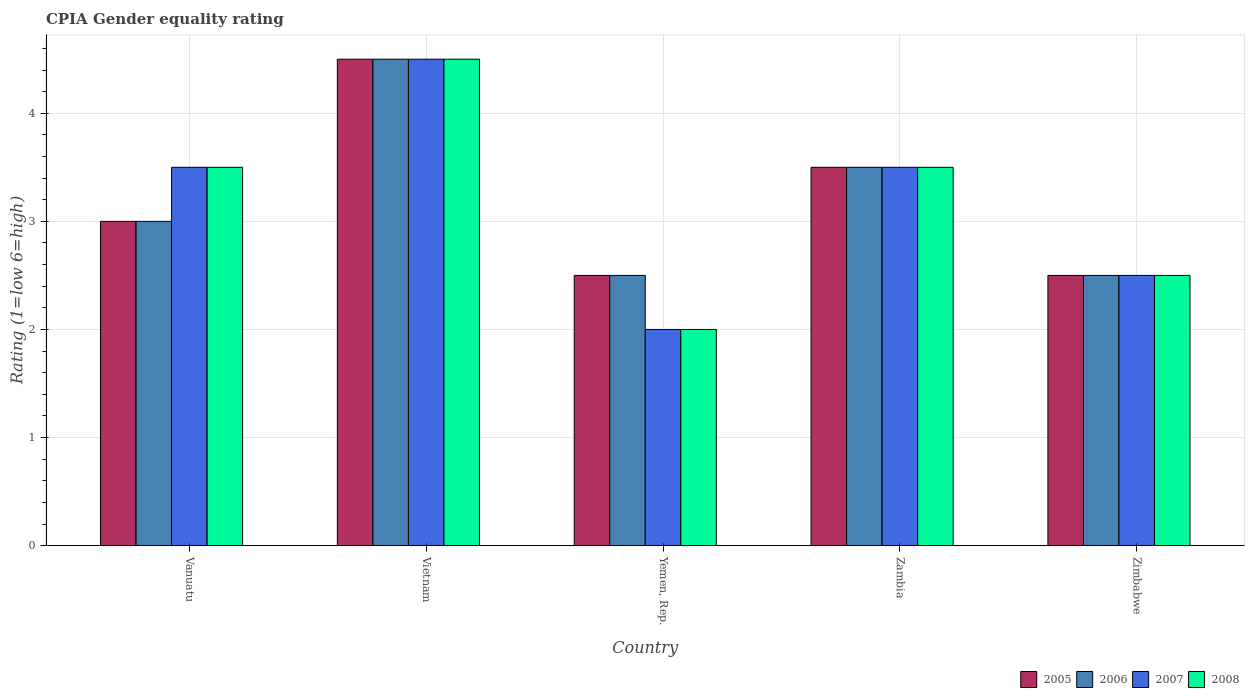How many different coloured bars are there?
Provide a succinct answer. 4. Are the number of bars per tick equal to the number of legend labels?
Your answer should be compact. Yes. Are the number of bars on each tick of the X-axis equal?
Your answer should be compact. Yes. What is the label of the 1st group of bars from the left?
Provide a succinct answer. Vanuatu. In how many cases, is the number of bars for a given country not equal to the number of legend labels?
Make the answer very short. 0. Across all countries, what is the maximum CPIA rating in 2005?
Offer a terse response. 4.5. In which country was the CPIA rating in 2006 maximum?
Ensure brevity in your answer.  Vietnam. In which country was the CPIA rating in 2008 minimum?
Keep it short and to the point. Yemen, Rep. What is the ratio of the CPIA rating in 2007 in Vietnam to that in Zimbabwe?
Give a very brief answer. 1.8. Is the CPIA rating in 2005 in Yemen, Rep. less than that in Zambia?
Your answer should be very brief. Yes. Is the difference between the CPIA rating in 2005 in Yemen, Rep. and Zimbabwe greater than the difference between the CPIA rating in 2008 in Yemen, Rep. and Zimbabwe?
Your response must be concise. Yes. What is the difference between the highest and the lowest CPIA rating in 2006?
Ensure brevity in your answer.  2. Is it the case that in every country, the sum of the CPIA rating in 2008 and CPIA rating in 2005 is greater than the sum of CPIA rating in 2007 and CPIA rating in 2006?
Provide a short and direct response. No. Is it the case that in every country, the sum of the CPIA rating in 2007 and CPIA rating in 2005 is greater than the CPIA rating in 2006?
Your answer should be compact. Yes. Are all the bars in the graph horizontal?
Your answer should be very brief. No. What is the difference between two consecutive major ticks on the Y-axis?
Offer a very short reply. 1. Are the values on the major ticks of Y-axis written in scientific E-notation?
Your answer should be compact. No. Does the graph contain grids?
Offer a very short reply. Yes. How many legend labels are there?
Make the answer very short. 4. How are the legend labels stacked?
Your answer should be very brief. Horizontal. What is the title of the graph?
Offer a terse response. CPIA Gender equality rating. What is the label or title of the X-axis?
Your response must be concise. Country. What is the Rating (1=low 6=high) of 2007 in Vanuatu?
Your answer should be compact. 3.5. What is the Rating (1=low 6=high) in 2007 in Vietnam?
Provide a short and direct response. 4.5. What is the Rating (1=low 6=high) in 2007 in Yemen, Rep.?
Your answer should be very brief. 2. What is the Rating (1=low 6=high) of 2008 in Zambia?
Ensure brevity in your answer.  3.5. What is the Rating (1=low 6=high) in 2005 in Zimbabwe?
Provide a succinct answer. 2.5. What is the Rating (1=low 6=high) of 2006 in Zimbabwe?
Ensure brevity in your answer.  2.5. What is the Rating (1=low 6=high) of 2008 in Zimbabwe?
Offer a very short reply. 2.5. Across all countries, what is the maximum Rating (1=low 6=high) of 2006?
Make the answer very short. 4.5. Across all countries, what is the maximum Rating (1=low 6=high) of 2007?
Provide a short and direct response. 4.5. Across all countries, what is the minimum Rating (1=low 6=high) of 2006?
Your answer should be very brief. 2.5. Across all countries, what is the minimum Rating (1=low 6=high) in 2007?
Your answer should be very brief. 2. What is the total Rating (1=low 6=high) in 2005 in the graph?
Offer a very short reply. 16. What is the total Rating (1=low 6=high) of 2006 in the graph?
Ensure brevity in your answer.  16. What is the difference between the Rating (1=low 6=high) in 2005 in Vanuatu and that in Vietnam?
Your response must be concise. -1.5. What is the difference between the Rating (1=low 6=high) of 2008 in Vanuatu and that in Vietnam?
Provide a succinct answer. -1. What is the difference between the Rating (1=low 6=high) of 2005 in Vanuatu and that in Yemen, Rep.?
Your answer should be compact. 0.5. What is the difference between the Rating (1=low 6=high) in 2006 in Vanuatu and that in Yemen, Rep.?
Provide a succinct answer. 0.5. What is the difference between the Rating (1=low 6=high) in 2007 in Vanuatu and that in Yemen, Rep.?
Give a very brief answer. 1.5. What is the difference between the Rating (1=low 6=high) of 2005 in Vanuatu and that in Zambia?
Your answer should be compact. -0.5. What is the difference between the Rating (1=low 6=high) in 2006 in Vanuatu and that in Zambia?
Your response must be concise. -0.5. What is the difference between the Rating (1=low 6=high) of 2005 in Vanuatu and that in Zimbabwe?
Provide a short and direct response. 0.5. What is the difference between the Rating (1=low 6=high) of 2006 in Vanuatu and that in Zimbabwe?
Your answer should be compact. 0.5. What is the difference between the Rating (1=low 6=high) of 2007 in Vietnam and that in Yemen, Rep.?
Provide a succinct answer. 2.5. What is the difference between the Rating (1=low 6=high) of 2008 in Vietnam and that in Yemen, Rep.?
Offer a very short reply. 2.5. What is the difference between the Rating (1=low 6=high) of 2005 in Vietnam and that in Zambia?
Offer a very short reply. 1. What is the difference between the Rating (1=low 6=high) in 2006 in Vietnam and that in Zambia?
Provide a short and direct response. 1. What is the difference between the Rating (1=low 6=high) in 2007 in Vietnam and that in Zambia?
Keep it short and to the point. 1. What is the difference between the Rating (1=low 6=high) in 2008 in Vietnam and that in Zambia?
Your answer should be compact. 1. What is the difference between the Rating (1=low 6=high) of 2005 in Vietnam and that in Zimbabwe?
Offer a terse response. 2. What is the difference between the Rating (1=low 6=high) in 2008 in Vietnam and that in Zimbabwe?
Offer a very short reply. 2. What is the difference between the Rating (1=low 6=high) in 2007 in Yemen, Rep. and that in Zambia?
Your answer should be compact. -1.5. What is the difference between the Rating (1=low 6=high) in 2006 in Yemen, Rep. and that in Zimbabwe?
Make the answer very short. 0. What is the difference between the Rating (1=low 6=high) in 2008 in Yemen, Rep. and that in Zimbabwe?
Offer a terse response. -0.5. What is the difference between the Rating (1=low 6=high) of 2006 in Zambia and that in Zimbabwe?
Your answer should be very brief. 1. What is the difference between the Rating (1=low 6=high) in 2007 in Zambia and that in Zimbabwe?
Provide a succinct answer. 1. What is the difference between the Rating (1=low 6=high) in 2005 in Vanuatu and the Rating (1=low 6=high) in 2006 in Vietnam?
Keep it short and to the point. -1.5. What is the difference between the Rating (1=low 6=high) in 2005 in Vanuatu and the Rating (1=low 6=high) in 2007 in Vietnam?
Give a very brief answer. -1.5. What is the difference between the Rating (1=low 6=high) in 2005 in Vanuatu and the Rating (1=low 6=high) in 2008 in Vietnam?
Keep it short and to the point. -1.5. What is the difference between the Rating (1=low 6=high) in 2006 in Vanuatu and the Rating (1=low 6=high) in 2007 in Vietnam?
Give a very brief answer. -1.5. What is the difference between the Rating (1=low 6=high) of 2007 in Vanuatu and the Rating (1=low 6=high) of 2008 in Vietnam?
Your response must be concise. -1. What is the difference between the Rating (1=low 6=high) in 2005 in Vanuatu and the Rating (1=low 6=high) in 2007 in Yemen, Rep.?
Provide a short and direct response. 1. What is the difference between the Rating (1=low 6=high) in 2007 in Vanuatu and the Rating (1=low 6=high) in 2008 in Yemen, Rep.?
Ensure brevity in your answer.  1.5. What is the difference between the Rating (1=low 6=high) in 2007 in Vanuatu and the Rating (1=low 6=high) in 2008 in Zambia?
Keep it short and to the point. 0. What is the difference between the Rating (1=low 6=high) in 2005 in Vanuatu and the Rating (1=low 6=high) in 2006 in Zimbabwe?
Offer a terse response. 0.5. What is the difference between the Rating (1=low 6=high) of 2006 in Vanuatu and the Rating (1=low 6=high) of 2008 in Zimbabwe?
Offer a very short reply. 0.5. What is the difference between the Rating (1=low 6=high) in 2007 in Vanuatu and the Rating (1=low 6=high) in 2008 in Zimbabwe?
Your response must be concise. 1. What is the difference between the Rating (1=low 6=high) in 2005 in Vietnam and the Rating (1=low 6=high) in 2006 in Yemen, Rep.?
Provide a short and direct response. 2. What is the difference between the Rating (1=low 6=high) in 2005 in Vietnam and the Rating (1=low 6=high) in 2007 in Yemen, Rep.?
Ensure brevity in your answer.  2.5. What is the difference between the Rating (1=low 6=high) in 2006 in Vietnam and the Rating (1=low 6=high) in 2007 in Yemen, Rep.?
Make the answer very short. 2.5. What is the difference between the Rating (1=low 6=high) in 2005 in Vietnam and the Rating (1=low 6=high) in 2007 in Zambia?
Offer a terse response. 1. What is the difference between the Rating (1=low 6=high) of 2005 in Vietnam and the Rating (1=low 6=high) of 2008 in Zambia?
Ensure brevity in your answer.  1. What is the difference between the Rating (1=low 6=high) in 2006 in Vietnam and the Rating (1=low 6=high) in 2007 in Zambia?
Make the answer very short. 1. What is the difference between the Rating (1=low 6=high) of 2006 in Vietnam and the Rating (1=low 6=high) of 2008 in Zambia?
Offer a very short reply. 1. What is the difference between the Rating (1=low 6=high) in 2007 in Vietnam and the Rating (1=low 6=high) in 2008 in Zambia?
Keep it short and to the point. 1. What is the difference between the Rating (1=low 6=high) of 2005 in Vietnam and the Rating (1=low 6=high) of 2006 in Zimbabwe?
Offer a very short reply. 2. What is the difference between the Rating (1=low 6=high) in 2006 in Vietnam and the Rating (1=low 6=high) in 2007 in Zimbabwe?
Your response must be concise. 2. What is the difference between the Rating (1=low 6=high) of 2007 in Vietnam and the Rating (1=low 6=high) of 2008 in Zimbabwe?
Give a very brief answer. 2. What is the difference between the Rating (1=low 6=high) in 2006 in Yemen, Rep. and the Rating (1=low 6=high) in 2007 in Zambia?
Ensure brevity in your answer.  -1. What is the difference between the Rating (1=low 6=high) in 2006 in Yemen, Rep. and the Rating (1=low 6=high) in 2008 in Zambia?
Keep it short and to the point. -1. What is the difference between the Rating (1=low 6=high) of 2007 in Yemen, Rep. and the Rating (1=low 6=high) of 2008 in Zambia?
Ensure brevity in your answer.  -1.5. What is the difference between the Rating (1=low 6=high) in 2005 in Yemen, Rep. and the Rating (1=low 6=high) in 2006 in Zimbabwe?
Keep it short and to the point. 0. What is the difference between the Rating (1=low 6=high) of 2005 in Yemen, Rep. and the Rating (1=low 6=high) of 2007 in Zimbabwe?
Your answer should be very brief. 0. What is the difference between the Rating (1=low 6=high) of 2005 in Yemen, Rep. and the Rating (1=low 6=high) of 2008 in Zimbabwe?
Provide a short and direct response. 0. What is the difference between the Rating (1=low 6=high) in 2007 in Yemen, Rep. and the Rating (1=low 6=high) in 2008 in Zimbabwe?
Your answer should be compact. -0.5. What is the difference between the Rating (1=low 6=high) in 2005 in Zambia and the Rating (1=low 6=high) in 2006 in Zimbabwe?
Ensure brevity in your answer.  1. What is the difference between the Rating (1=low 6=high) in 2005 in Zambia and the Rating (1=low 6=high) in 2008 in Zimbabwe?
Offer a very short reply. 1. What is the difference between the Rating (1=low 6=high) of 2006 in Zambia and the Rating (1=low 6=high) of 2007 in Zimbabwe?
Make the answer very short. 1. What is the difference between the Rating (1=low 6=high) of 2006 in Zambia and the Rating (1=low 6=high) of 2008 in Zimbabwe?
Provide a short and direct response. 1. What is the difference between the Rating (1=low 6=high) in 2007 in Zambia and the Rating (1=low 6=high) in 2008 in Zimbabwe?
Keep it short and to the point. 1. What is the average Rating (1=low 6=high) in 2006 per country?
Offer a terse response. 3.2. What is the average Rating (1=low 6=high) in 2008 per country?
Provide a short and direct response. 3.2. What is the difference between the Rating (1=low 6=high) in 2005 and Rating (1=low 6=high) in 2006 in Vanuatu?
Your answer should be compact. 0. What is the difference between the Rating (1=low 6=high) of 2005 and Rating (1=low 6=high) of 2007 in Vanuatu?
Make the answer very short. -0.5. What is the difference between the Rating (1=low 6=high) of 2005 and Rating (1=low 6=high) of 2008 in Vanuatu?
Ensure brevity in your answer.  -0.5. What is the difference between the Rating (1=low 6=high) in 2006 and Rating (1=low 6=high) in 2007 in Vanuatu?
Give a very brief answer. -0.5. What is the difference between the Rating (1=low 6=high) in 2006 and Rating (1=low 6=high) in 2008 in Vanuatu?
Offer a very short reply. -0.5. What is the difference between the Rating (1=low 6=high) in 2007 and Rating (1=low 6=high) in 2008 in Vanuatu?
Your answer should be compact. 0. What is the difference between the Rating (1=low 6=high) in 2005 and Rating (1=low 6=high) in 2008 in Vietnam?
Offer a terse response. 0. What is the difference between the Rating (1=low 6=high) in 2006 and Rating (1=low 6=high) in 2008 in Vietnam?
Your response must be concise. 0. What is the difference between the Rating (1=low 6=high) in 2007 and Rating (1=low 6=high) in 2008 in Vietnam?
Provide a succinct answer. 0. What is the difference between the Rating (1=low 6=high) in 2005 and Rating (1=low 6=high) in 2006 in Yemen, Rep.?
Give a very brief answer. 0. What is the difference between the Rating (1=low 6=high) of 2005 and Rating (1=low 6=high) of 2007 in Yemen, Rep.?
Give a very brief answer. 0.5. What is the difference between the Rating (1=low 6=high) of 2006 and Rating (1=low 6=high) of 2007 in Yemen, Rep.?
Keep it short and to the point. 0.5. What is the difference between the Rating (1=low 6=high) of 2006 and Rating (1=low 6=high) of 2008 in Yemen, Rep.?
Your answer should be very brief. 0.5. What is the difference between the Rating (1=low 6=high) in 2007 and Rating (1=low 6=high) in 2008 in Yemen, Rep.?
Keep it short and to the point. 0. What is the difference between the Rating (1=low 6=high) of 2005 and Rating (1=low 6=high) of 2007 in Zambia?
Provide a short and direct response. 0. What is the difference between the Rating (1=low 6=high) in 2005 and Rating (1=low 6=high) in 2008 in Zambia?
Ensure brevity in your answer.  0. What is the difference between the Rating (1=low 6=high) in 2006 and Rating (1=low 6=high) in 2007 in Zambia?
Your answer should be compact. 0. What is the difference between the Rating (1=low 6=high) in 2006 and Rating (1=low 6=high) in 2008 in Zambia?
Ensure brevity in your answer.  0. What is the difference between the Rating (1=low 6=high) in 2005 and Rating (1=low 6=high) in 2006 in Zimbabwe?
Your response must be concise. 0. What is the difference between the Rating (1=low 6=high) in 2005 and Rating (1=low 6=high) in 2008 in Zimbabwe?
Ensure brevity in your answer.  0. What is the difference between the Rating (1=low 6=high) of 2006 and Rating (1=low 6=high) of 2007 in Zimbabwe?
Give a very brief answer. 0. What is the ratio of the Rating (1=low 6=high) of 2007 in Vanuatu to that in Vietnam?
Offer a terse response. 0.78. What is the ratio of the Rating (1=low 6=high) in 2008 in Vanuatu to that in Vietnam?
Offer a terse response. 0.78. What is the ratio of the Rating (1=low 6=high) in 2005 in Vanuatu to that in Yemen, Rep.?
Your answer should be very brief. 1.2. What is the ratio of the Rating (1=low 6=high) in 2006 in Vanuatu to that in Yemen, Rep.?
Your response must be concise. 1.2. What is the ratio of the Rating (1=low 6=high) of 2008 in Vanuatu to that in Yemen, Rep.?
Keep it short and to the point. 1.75. What is the ratio of the Rating (1=low 6=high) in 2007 in Vanuatu to that in Zambia?
Provide a succinct answer. 1. What is the ratio of the Rating (1=low 6=high) of 2006 in Vanuatu to that in Zimbabwe?
Offer a terse response. 1.2. What is the ratio of the Rating (1=low 6=high) of 2005 in Vietnam to that in Yemen, Rep.?
Your response must be concise. 1.8. What is the ratio of the Rating (1=low 6=high) in 2007 in Vietnam to that in Yemen, Rep.?
Make the answer very short. 2.25. What is the ratio of the Rating (1=low 6=high) of 2008 in Vietnam to that in Yemen, Rep.?
Your answer should be compact. 2.25. What is the ratio of the Rating (1=low 6=high) of 2006 in Vietnam to that in Zambia?
Ensure brevity in your answer.  1.29. What is the ratio of the Rating (1=low 6=high) of 2007 in Vietnam to that in Zambia?
Ensure brevity in your answer.  1.29. What is the ratio of the Rating (1=low 6=high) of 2008 in Vietnam to that in Zambia?
Provide a succinct answer. 1.29. What is the ratio of the Rating (1=low 6=high) in 2006 in Vietnam to that in Zimbabwe?
Give a very brief answer. 1.8. What is the ratio of the Rating (1=low 6=high) in 2005 in Yemen, Rep. to that in Zambia?
Keep it short and to the point. 0.71. What is the ratio of the Rating (1=low 6=high) of 2006 in Yemen, Rep. to that in Zambia?
Provide a short and direct response. 0.71. What is the ratio of the Rating (1=low 6=high) of 2005 in Yemen, Rep. to that in Zimbabwe?
Give a very brief answer. 1. What is the ratio of the Rating (1=low 6=high) in 2008 in Yemen, Rep. to that in Zimbabwe?
Make the answer very short. 0.8. What is the ratio of the Rating (1=low 6=high) in 2006 in Zambia to that in Zimbabwe?
Ensure brevity in your answer.  1.4. What is the ratio of the Rating (1=low 6=high) in 2007 in Zambia to that in Zimbabwe?
Provide a short and direct response. 1.4. What is the ratio of the Rating (1=low 6=high) of 2008 in Zambia to that in Zimbabwe?
Your response must be concise. 1.4. What is the difference between the highest and the lowest Rating (1=low 6=high) in 2005?
Give a very brief answer. 2. What is the difference between the highest and the lowest Rating (1=low 6=high) in 2007?
Your answer should be very brief. 2.5. What is the difference between the highest and the lowest Rating (1=low 6=high) of 2008?
Provide a succinct answer. 2.5. 